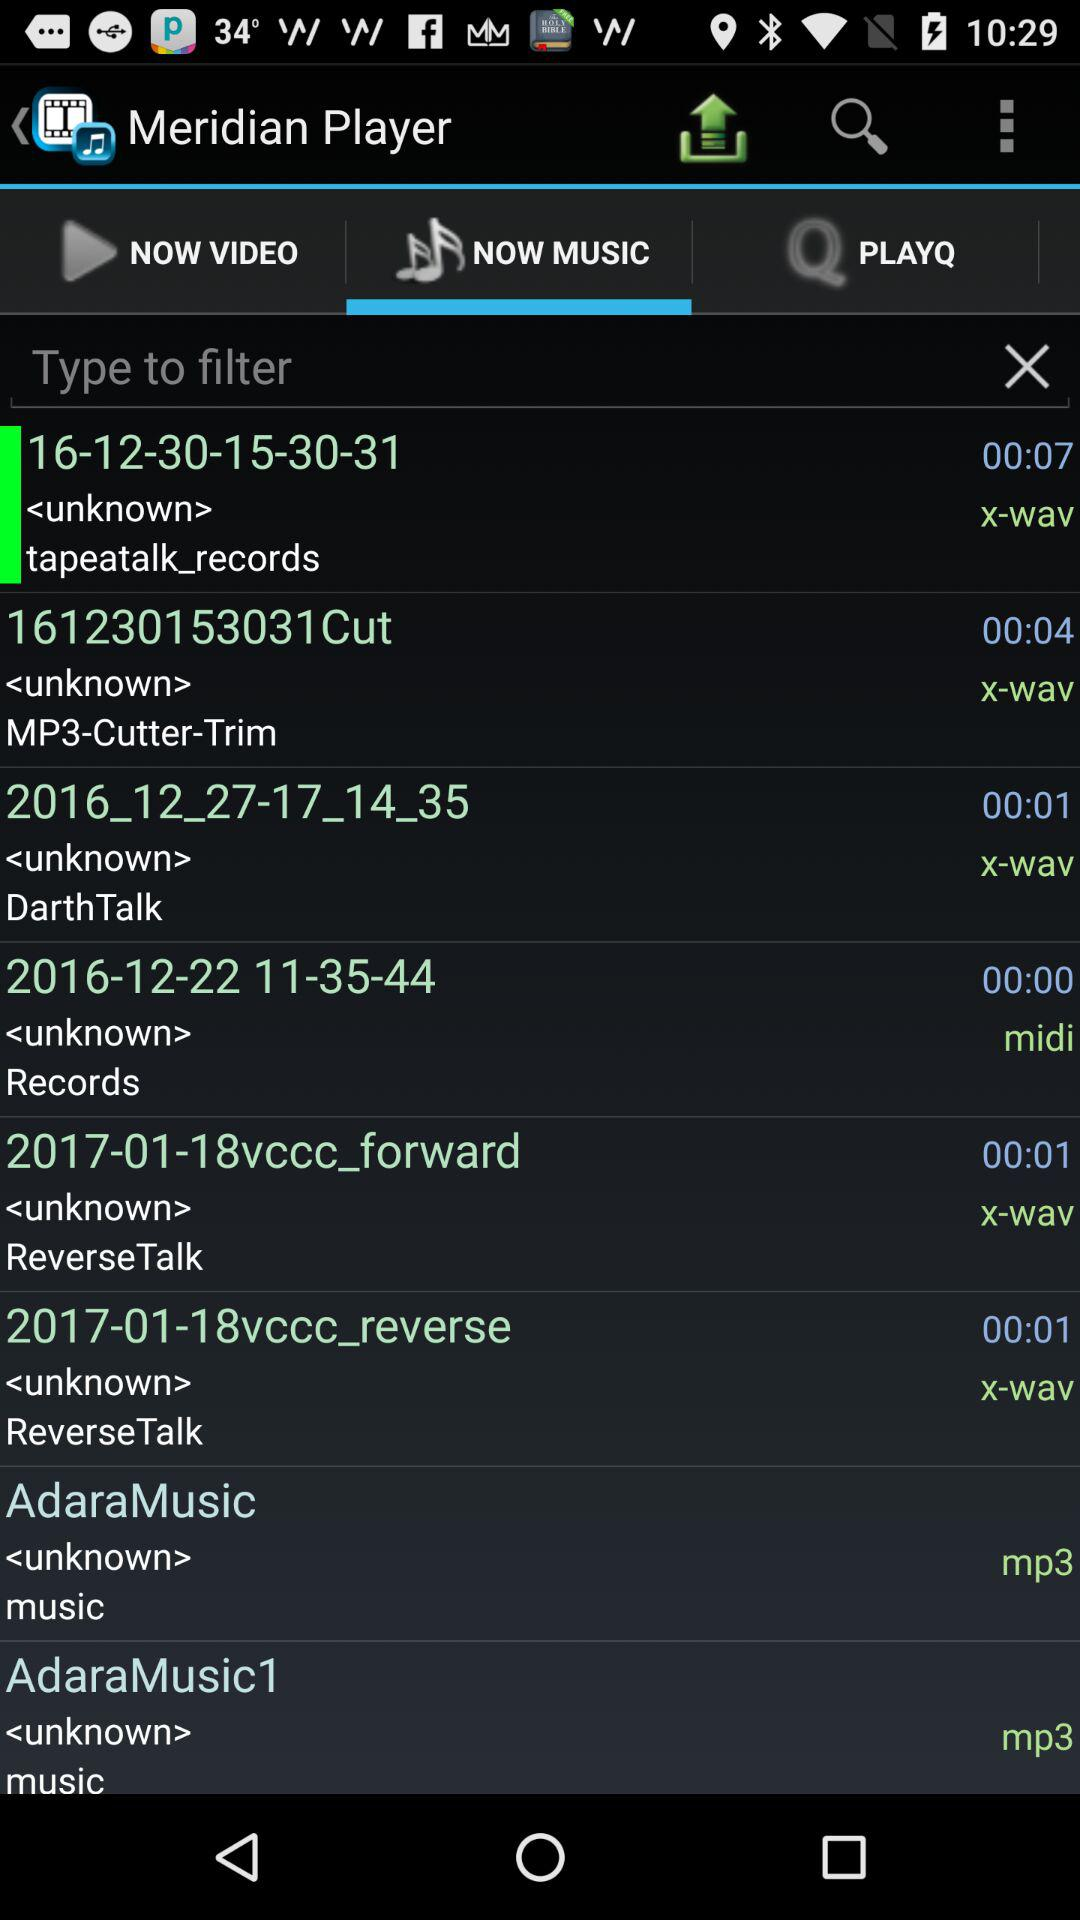How many notifications are there in "NOW VIDEO"?
When the provided information is insufficient, respond with <no answer>. <no answer> 